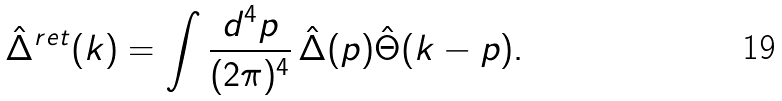Convert formula to latex. <formula><loc_0><loc_0><loc_500><loc_500>\hat { \Delta } ^ { r e t } ( k ) = \int \frac { d ^ { 4 } p } { ( 2 \pi ) ^ { 4 } } \, \hat { \Delta } ( p ) \hat { \Theta } ( k - p ) .</formula> 